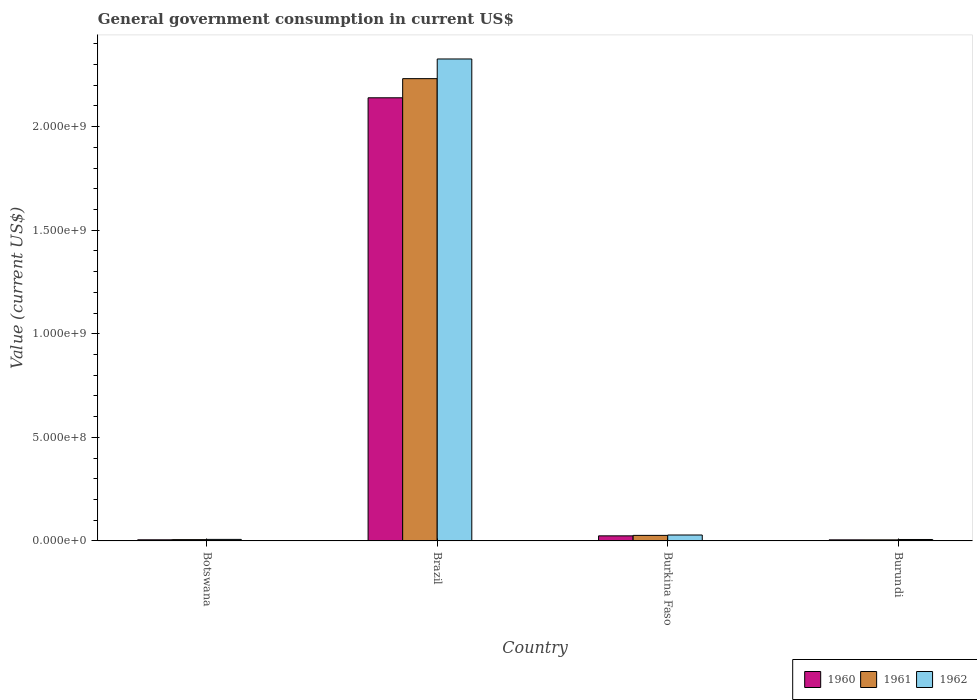Are the number of bars per tick equal to the number of legend labels?
Offer a terse response. Yes. Are the number of bars on each tick of the X-axis equal?
Your answer should be very brief. Yes. How many bars are there on the 2nd tick from the right?
Offer a terse response. 3. What is the label of the 4th group of bars from the left?
Your response must be concise. Burundi. In how many cases, is the number of bars for a given country not equal to the number of legend labels?
Your answer should be compact. 0. What is the government conusmption in 1960 in Brazil?
Ensure brevity in your answer.  2.14e+09. Across all countries, what is the maximum government conusmption in 1960?
Provide a succinct answer. 2.14e+09. Across all countries, what is the minimum government conusmption in 1960?
Your answer should be compact. 5.25e+06. In which country was the government conusmption in 1962 minimum?
Ensure brevity in your answer.  Burundi. What is the total government conusmption in 1960 in the graph?
Your answer should be very brief. 2.17e+09. What is the difference between the government conusmption in 1960 in Brazil and that in Burkina Faso?
Offer a very short reply. 2.11e+09. What is the difference between the government conusmption in 1962 in Burkina Faso and the government conusmption in 1961 in Burundi?
Make the answer very short. 2.34e+07. What is the average government conusmption in 1960 per country?
Offer a terse response. 5.44e+08. What is the difference between the government conusmption of/in 1960 and government conusmption of/in 1962 in Brazil?
Offer a very short reply. -1.87e+08. What is the ratio of the government conusmption in 1962 in Botswana to that in Burkina Faso?
Provide a short and direct response. 0.26. What is the difference between the highest and the second highest government conusmption in 1962?
Ensure brevity in your answer.  2.12e+07. What is the difference between the highest and the lowest government conusmption in 1962?
Offer a terse response. 2.32e+09. In how many countries, is the government conusmption in 1961 greater than the average government conusmption in 1961 taken over all countries?
Your answer should be compact. 1. What does the 3rd bar from the right in Burkina Faso represents?
Your answer should be compact. 1960. Is it the case that in every country, the sum of the government conusmption in 1961 and government conusmption in 1962 is greater than the government conusmption in 1960?
Provide a succinct answer. Yes. How many bars are there?
Give a very brief answer. 12. Are all the bars in the graph horizontal?
Your response must be concise. No. Does the graph contain grids?
Your response must be concise. No. How are the legend labels stacked?
Ensure brevity in your answer.  Horizontal. What is the title of the graph?
Ensure brevity in your answer.  General government consumption in current US$. Does "1973" appear as one of the legend labels in the graph?
Your answer should be very brief. No. What is the label or title of the X-axis?
Make the answer very short. Country. What is the label or title of the Y-axis?
Offer a terse response. Value (current US$). What is the Value (current US$) of 1960 in Botswana?
Your answer should be compact. 5.52e+06. What is the Value (current US$) of 1961 in Botswana?
Give a very brief answer. 6.40e+06. What is the Value (current US$) of 1962 in Botswana?
Offer a terse response. 7.45e+06. What is the Value (current US$) of 1960 in Brazil?
Keep it short and to the point. 2.14e+09. What is the Value (current US$) in 1961 in Brazil?
Ensure brevity in your answer.  2.23e+09. What is the Value (current US$) of 1962 in Brazil?
Offer a very short reply. 2.33e+09. What is the Value (current US$) of 1960 in Burkina Faso?
Offer a very short reply. 2.45e+07. What is the Value (current US$) in 1961 in Burkina Faso?
Offer a very short reply. 2.68e+07. What is the Value (current US$) in 1962 in Burkina Faso?
Offer a very short reply. 2.87e+07. What is the Value (current US$) of 1960 in Burundi?
Make the answer very short. 5.25e+06. What is the Value (current US$) in 1961 in Burundi?
Provide a succinct answer. 5.25e+06. Across all countries, what is the maximum Value (current US$) in 1960?
Keep it short and to the point. 2.14e+09. Across all countries, what is the maximum Value (current US$) in 1961?
Give a very brief answer. 2.23e+09. Across all countries, what is the maximum Value (current US$) of 1962?
Offer a terse response. 2.33e+09. Across all countries, what is the minimum Value (current US$) in 1960?
Your answer should be compact. 5.25e+06. Across all countries, what is the minimum Value (current US$) of 1961?
Your answer should be compact. 5.25e+06. What is the total Value (current US$) in 1960 in the graph?
Make the answer very short. 2.17e+09. What is the total Value (current US$) in 1961 in the graph?
Your answer should be very brief. 2.27e+09. What is the total Value (current US$) in 1962 in the graph?
Provide a succinct answer. 2.37e+09. What is the difference between the Value (current US$) in 1960 in Botswana and that in Brazil?
Give a very brief answer. -2.13e+09. What is the difference between the Value (current US$) in 1961 in Botswana and that in Brazil?
Your answer should be very brief. -2.23e+09. What is the difference between the Value (current US$) in 1962 in Botswana and that in Brazil?
Ensure brevity in your answer.  -2.32e+09. What is the difference between the Value (current US$) of 1960 in Botswana and that in Burkina Faso?
Offer a very short reply. -1.90e+07. What is the difference between the Value (current US$) of 1961 in Botswana and that in Burkina Faso?
Offer a very short reply. -2.04e+07. What is the difference between the Value (current US$) of 1962 in Botswana and that in Burkina Faso?
Offer a terse response. -2.12e+07. What is the difference between the Value (current US$) in 1960 in Botswana and that in Burundi?
Your answer should be very brief. 2.65e+05. What is the difference between the Value (current US$) of 1961 in Botswana and that in Burundi?
Provide a succinct answer. 1.15e+06. What is the difference between the Value (current US$) in 1962 in Botswana and that in Burundi?
Offer a very short reply. 4.54e+05. What is the difference between the Value (current US$) in 1960 in Brazil and that in Burkina Faso?
Make the answer very short. 2.11e+09. What is the difference between the Value (current US$) of 1961 in Brazil and that in Burkina Faso?
Give a very brief answer. 2.20e+09. What is the difference between the Value (current US$) of 1962 in Brazil and that in Burkina Faso?
Provide a short and direct response. 2.30e+09. What is the difference between the Value (current US$) in 1960 in Brazil and that in Burundi?
Provide a short and direct response. 2.13e+09. What is the difference between the Value (current US$) in 1961 in Brazil and that in Burundi?
Give a very brief answer. 2.23e+09. What is the difference between the Value (current US$) of 1962 in Brazil and that in Burundi?
Ensure brevity in your answer.  2.32e+09. What is the difference between the Value (current US$) of 1960 in Burkina Faso and that in Burundi?
Make the answer very short. 1.93e+07. What is the difference between the Value (current US$) of 1961 in Burkina Faso and that in Burundi?
Your answer should be very brief. 2.16e+07. What is the difference between the Value (current US$) of 1962 in Burkina Faso and that in Burundi?
Ensure brevity in your answer.  2.17e+07. What is the difference between the Value (current US$) of 1960 in Botswana and the Value (current US$) of 1961 in Brazil?
Give a very brief answer. -2.23e+09. What is the difference between the Value (current US$) in 1960 in Botswana and the Value (current US$) in 1962 in Brazil?
Your response must be concise. -2.32e+09. What is the difference between the Value (current US$) in 1961 in Botswana and the Value (current US$) in 1962 in Brazil?
Your response must be concise. -2.32e+09. What is the difference between the Value (current US$) in 1960 in Botswana and the Value (current US$) in 1961 in Burkina Faso?
Provide a short and direct response. -2.13e+07. What is the difference between the Value (current US$) of 1960 in Botswana and the Value (current US$) of 1962 in Burkina Faso?
Ensure brevity in your answer.  -2.31e+07. What is the difference between the Value (current US$) of 1961 in Botswana and the Value (current US$) of 1962 in Burkina Faso?
Offer a very short reply. -2.23e+07. What is the difference between the Value (current US$) of 1960 in Botswana and the Value (current US$) of 1961 in Burundi?
Your answer should be very brief. 2.65e+05. What is the difference between the Value (current US$) in 1960 in Botswana and the Value (current US$) in 1962 in Burundi?
Offer a terse response. -1.48e+06. What is the difference between the Value (current US$) of 1961 in Botswana and the Value (current US$) of 1962 in Burundi?
Your answer should be compact. -6.03e+05. What is the difference between the Value (current US$) of 1960 in Brazil and the Value (current US$) of 1961 in Burkina Faso?
Your answer should be compact. 2.11e+09. What is the difference between the Value (current US$) of 1960 in Brazil and the Value (current US$) of 1962 in Burkina Faso?
Provide a short and direct response. 2.11e+09. What is the difference between the Value (current US$) in 1961 in Brazil and the Value (current US$) in 1962 in Burkina Faso?
Your answer should be compact. 2.20e+09. What is the difference between the Value (current US$) in 1960 in Brazil and the Value (current US$) in 1961 in Burundi?
Keep it short and to the point. 2.13e+09. What is the difference between the Value (current US$) of 1960 in Brazil and the Value (current US$) of 1962 in Burundi?
Provide a succinct answer. 2.13e+09. What is the difference between the Value (current US$) in 1961 in Brazil and the Value (current US$) in 1962 in Burundi?
Your answer should be compact. 2.22e+09. What is the difference between the Value (current US$) in 1960 in Burkina Faso and the Value (current US$) in 1961 in Burundi?
Your answer should be compact. 1.93e+07. What is the difference between the Value (current US$) in 1960 in Burkina Faso and the Value (current US$) in 1962 in Burundi?
Provide a succinct answer. 1.75e+07. What is the difference between the Value (current US$) in 1961 in Burkina Faso and the Value (current US$) in 1962 in Burundi?
Give a very brief answer. 1.98e+07. What is the average Value (current US$) of 1960 per country?
Offer a very short reply. 5.44e+08. What is the average Value (current US$) in 1961 per country?
Provide a succinct answer. 5.67e+08. What is the average Value (current US$) of 1962 per country?
Offer a very short reply. 5.92e+08. What is the difference between the Value (current US$) of 1960 and Value (current US$) of 1961 in Botswana?
Give a very brief answer. -8.82e+05. What is the difference between the Value (current US$) in 1960 and Value (current US$) in 1962 in Botswana?
Provide a short and direct response. -1.94e+06. What is the difference between the Value (current US$) in 1961 and Value (current US$) in 1962 in Botswana?
Keep it short and to the point. -1.06e+06. What is the difference between the Value (current US$) in 1960 and Value (current US$) in 1961 in Brazil?
Ensure brevity in your answer.  -9.24e+07. What is the difference between the Value (current US$) in 1960 and Value (current US$) in 1962 in Brazil?
Your answer should be very brief. -1.87e+08. What is the difference between the Value (current US$) of 1961 and Value (current US$) of 1962 in Brazil?
Keep it short and to the point. -9.50e+07. What is the difference between the Value (current US$) of 1960 and Value (current US$) of 1961 in Burkina Faso?
Provide a short and direct response. -2.27e+06. What is the difference between the Value (current US$) of 1960 and Value (current US$) of 1962 in Burkina Faso?
Provide a succinct answer. -4.11e+06. What is the difference between the Value (current US$) in 1961 and Value (current US$) in 1962 in Burkina Faso?
Provide a succinct answer. -1.84e+06. What is the difference between the Value (current US$) in 1960 and Value (current US$) in 1961 in Burundi?
Give a very brief answer. 0. What is the difference between the Value (current US$) of 1960 and Value (current US$) of 1962 in Burundi?
Your answer should be compact. -1.75e+06. What is the difference between the Value (current US$) of 1961 and Value (current US$) of 1962 in Burundi?
Ensure brevity in your answer.  -1.75e+06. What is the ratio of the Value (current US$) of 1960 in Botswana to that in Brazil?
Keep it short and to the point. 0. What is the ratio of the Value (current US$) of 1961 in Botswana to that in Brazil?
Your answer should be very brief. 0. What is the ratio of the Value (current US$) in 1962 in Botswana to that in Brazil?
Keep it short and to the point. 0. What is the ratio of the Value (current US$) in 1960 in Botswana to that in Burkina Faso?
Give a very brief answer. 0.22. What is the ratio of the Value (current US$) of 1961 in Botswana to that in Burkina Faso?
Provide a short and direct response. 0.24. What is the ratio of the Value (current US$) in 1962 in Botswana to that in Burkina Faso?
Your response must be concise. 0.26. What is the ratio of the Value (current US$) of 1960 in Botswana to that in Burundi?
Ensure brevity in your answer.  1.05. What is the ratio of the Value (current US$) of 1961 in Botswana to that in Burundi?
Provide a short and direct response. 1.22. What is the ratio of the Value (current US$) of 1962 in Botswana to that in Burundi?
Your response must be concise. 1.06. What is the ratio of the Value (current US$) of 1960 in Brazil to that in Burkina Faso?
Your answer should be compact. 87.16. What is the ratio of the Value (current US$) in 1961 in Brazil to that in Burkina Faso?
Offer a terse response. 83.24. What is the ratio of the Value (current US$) of 1962 in Brazil to that in Burkina Faso?
Your response must be concise. 81.2. What is the ratio of the Value (current US$) in 1960 in Brazil to that in Burundi?
Ensure brevity in your answer.  407.42. What is the ratio of the Value (current US$) of 1961 in Brazil to that in Burundi?
Give a very brief answer. 425.03. What is the ratio of the Value (current US$) in 1962 in Brazil to that in Burundi?
Ensure brevity in your answer.  332.34. What is the ratio of the Value (current US$) of 1960 in Burkina Faso to that in Burundi?
Your response must be concise. 4.67. What is the ratio of the Value (current US$) in 1961 in Burkina Faso to that in Burundi?
Ensure brevity in your answer.  5.11. What is the ratio of the Value (current US$) of 1962 in Burkina Faso to that in Burundi?
Provide a succinct answer. 4.09. What is the difference between the highest and the second highest Value (current US$) of 1960?
Offer a terse response. 2.11e+09. What is the difference between the highest and the second highest Value (current US$) of 1961?
Provide a short and direct response. 2.20e+09. What is the difference between the highest and the second highest Value (current US$) in 1962?
Give a very brief answer. 2.30e+09. What is the difference between the highest and the lowest Value (current US$) of 1960?
Make the answer very short. 2.13e+09. What is the difference between the highest and the lowest Value (current US$) in 1961?
Provide a succinct answer. 2.23e+09. What is the difference between the highest and the lowest Value (current US$) of 1962?
Offer a terse response. 2.32e+09. 